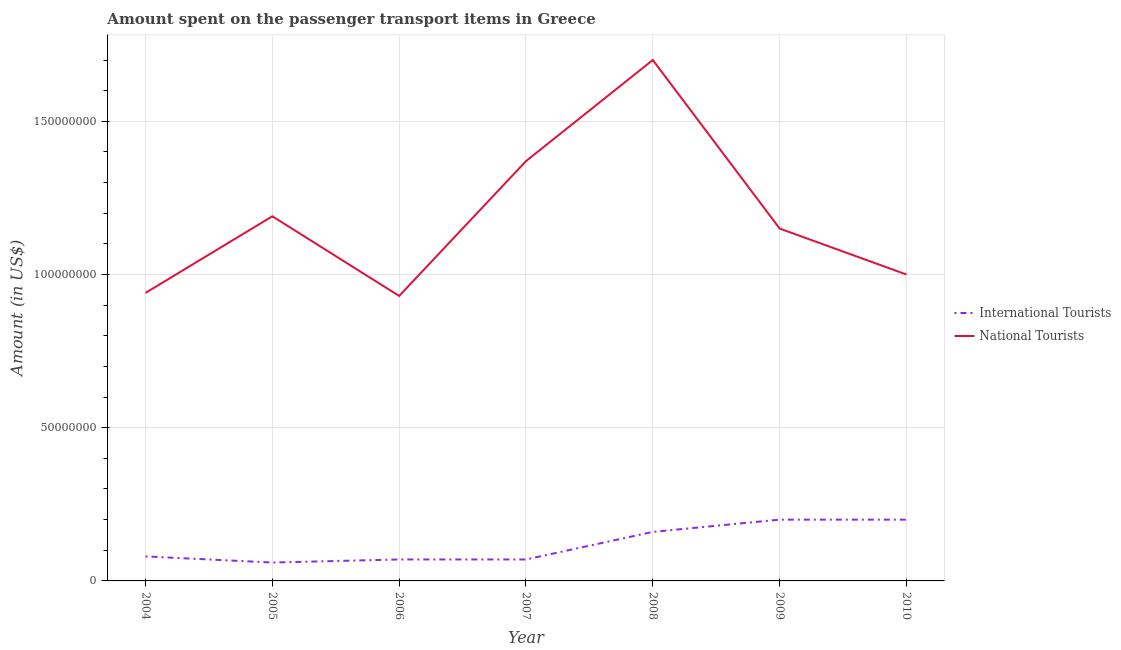How many different coloured lines are there?
Make the answer very short. 2. What is the amount spent on transport items of national tourists in 2007?
Offer a very short reply. 1.37e+08. Across all years, what is the maximum amount spent on transport items of international tourists?
Your response must be concise. 2.00e+07. Across all years, what is the minimum amount spent on transport items of national tourists?
Offer a terse response. 9.30e+07. In which year was the amount spent on transport items of national tourists minimum?
Your answer should be compact. 2006. What is the total amount spent on transport items of international tourists in the graph?
Provide a succinct answer. 8.40e+07. What is the difference between the amount spent on transport items of national tourists in 2007 and that in 2010?
Offer a very short reply. 3.70e+07. What is the difference between the amount spent on transport items of international tourists in 2007 and the amount spent on transport items of national tourists in 2009?
Give a very brief answer. -1.08e+08. What is the average amount spent on transport items of international tourists per year?
Provide a succinct answer. 1.20e+07. In the year 2005, what is the difference between the amount spent on transport items of international tourists and amount spent on transport items of national tourists?
Your answer should be very brief. -1.13e+08. In how many years, is the amount spent on transport items of national tourists greater than 110000000 US$?
Your answer should be compact. 4. What is the difference between the highest and the second highest amount spent on transport items of international tourists?
Offer a very short reply. 0. What is the difference between the highest and the lowest amount spent on transport items of international tourists?
Provide a succinct answer. 1.40e+07. Does the amount spent on transport items of international tourists monotonically increase over the years?
Your answer should be very brief. No. How many lines are there?
Your answer should be very brief. 2. How many years are there in the graph?
Your answer should be very brief. 7. What is the title of the graph?
Keep it short and to the point. Amount spent on the passenger transport items in Greece. Does "Secondary" appear as one of the legend labels in the graph?
Make the answer very short. No. What is the label or title of the X-axis?
Provide a short and direct response. Year. What is the Amount (in US$) in International Tourists in 2004?
Your response must be concise. 8.00e+06. What is the Amount (in US$) in National Tourists in 2004?
Give a very brief answer. 9.40e+07. What is the Amount (in US$) of National Tourists in 2005?
Provide a succinct answer. 1.19e+08. What is the Amount (in US$) of International Tourists in 2006?
Offer a very short reply. 7.00e+06. What is the Amount (in US$) in National Tourists in 2006?
Give a very brief answer. 9.30e+07. What is the Amount (in US$) in National Tourists in 2007?
Offer a very short reply. 1.37e+08. What is the Amount (in US$) in International Tourists in 2008?
Offer a terse response. 1.60e+07. What is the Amount (in US$) of National Tourists in 2008?
Your answer should be compact. 1.70e+08. What is the Amount (in US$) in National Tourists in 2009?
Provide a short and direct response. 1.15e+08. What is the Amount (in US$) of National Tourists in 2010?
Your answer should be very brief. 1.00e+08. Across all years, what is the maximum Amount (in US$) in International Tourists?
Your response must be concise. 2.00e+07. Across all years, what is the maximum Amount (in US$) in National Tourists?
Your answer should be very brief. 1.70e+08. Across all years, what is the minimum Amount (in US$) in National Tourists?
Keep it short and to the point. 9.30e+07. What is the total Amount (in US$) in International Tourists in the graph?
Your response must be concise. 8.40e+07. What is the total Amount (in US$) in National Tourists in the graph?
Ensure brevity in your answer.  8.28e+08. What is the difference between the Amount (in US$) of International Tourists in 2004 and that in 2005?
Give a very brief answer. 2.00e+06. What is the difference between the Amount (in US$) in National Tourists in 2004 and that in 2005?
Offer a terse response. -2.50e+07. What is the difference between the Amount (in US$) of International Tourists in 2004 and that in 2006?
Your response must be concise. 1.00e+06. What is the difference between the Amount (in US$) in National Tourists in 2004 and that in 2007?
Ensure brevity in your answer.  -4.30e+07. What is the difference between the Amount (in US$) in International Tourists in 2004 and that in 2008?
Offer a terse response. -8.00e+06. What is the difference between the Amount (in US$) of National Tourists in 2004 and that in 2008?
Provide a succinct answer. -7.60e+07. What is the difference between the Amount (in US$) in International Tourists in 2004 and that in 2009?
Your answer should be very brief. -1.20e+07. What is the difference between the Amount (in US$) in National Tourists in 2004 and that in 2009?
Provide a short and direct response. -2.10e+07. What is the difference between the Amount (in US$) of International Tourists in 2004 and that in 2010?
Make the answer very short. -1.20e+07. What is the difference between the Amount (in US$) in National Tourists in 2004 and that in 2010?
Your response must be concise. -6.00e+06. What is the difference between the Amount (in US$) in National Tourists in 2005 and that in 2006?
Make the answer very short. 2.60e+07. What is the difference between the Amount (in US$) of International Tourists in 2005 and that in 2007?
Ensure brevity in your answer.  -1.00e+06. What is the difference between the Amount (in US$) in National Tourists in 2005 and that in 2007?
Give a very brief answer. -1.80e+07. What is the difference between the Amount (in US$) of International Tourists in 2005 and that in 2008?
Your answer should be compact. -1.00e+07. What is the difference between the Amount (in US$) of National Tourists in 2005 and that in 2008?
Provide a succinct answer. -5.10e+07. What is the difference between the Amount (in US$) in International Tourists in 2005 and that in 2009?
Provide a short and direct response. -1.40e+07. What is the difference between the Amount (in US$) of International Tourists in 2005 and that in 2010?
Provide a short and direct response. -1.40e+07. What is the difference between the Amount (in US$) in National Tourists in 2005 and that in 2010?
Provide a succinct answer. 1.90e+07. What is the difference between the Amount (in US$) of National Tourists in 2006 and that in 2007?
Your answer should be very brief. -4.40e+07. What is the difference between the Amount (in US$) in International Tourists in 2006 and that in 2008?
Ensure brevity in your answer.  -9.00e+06. What is the difference between the Amount (in US$) in National Tourists in 2006 and that in 2008?
Make the answer very short. -7.70e+07. What is the difference between the Amount (in US$) of International Tourists in 2006 and that in 2009?
Your answer should be compact. -1.30e+07. What is the difference between the Amount (in US$) in National Tourists in 2006 and that in 2009?
Your response must be concise. -2.20e+07. What is the difference between the Amount (in US$) of International Tourists in 2006 and that in 2010?
Your answer should be very brief. -1.30e+07. What is the difference between the Amount (in US$) of National Tourists in 2006 and that in 2010?
Make the answer very short. -7.00e+06. What is the difference between the Amount (in US$) of International Tourists in 2007 and that in 2008?
Your answer should be compact. -9.00e+06. What is the difference between the Amount (in US$) in National Tourists in 2007 and that in 2008?
Offer a terse response. -3.30e+07. What is the difference between the Amount (in US$) in International Tourists in 2007 and that in 2009?
Your answer should be very brief. -1.30e+07. What is the difference between the Amount (in US$) in National Tourists in 2007 and that in 2009?
Your answer should be compact. 2.20e+07. What is the difference between the Amount (in US$) in International Tourists in 2007 and that in 2010?
Provide a short and direct response. -1.30e+07. What is the difference between the Amount (in US$) of National Tourists in 2007 and that in 2010?
Provide a succinct answer. 3.70e+07. What is the difference between the Amount (in US$) of National Tourists in 2008 and that in 2009?
Make the answer very short. 5.50e+07. What is the difference between the Amount (in US$) of International Tourists in 2008 and that in 2010?
Your answer should be very brief. -4.00e+06. What is the difference between the Amount (in US$) of National Tourists in 2008 and that in 2010?
Give a very brief answer. 7.00e+07. What is the difference between the Amount (in US$) of National Tourists in 2009 and that in 2010?
Provide a succinct answer. 1.50e+07. What is the difference between the Amount (in US$) in International Tourists in 2004 and the Amount (in US$) in National Tourists in 2005?
Give a very brief answer. -1.11e+08. What is the difference between the Amount (in US$) of International Tourists in 2004 and the Amount (in US$) of National Tourists in 2006?
Make the answer very short. -8.50e+07. What is the difference between the Amount (in US$) of International Tourists in 2004 and the Amount (in US$) of National Tourists in 2007?
Offer a terse response. -1.29e+08. What is the difference between the Amount (in US$) of International Tourists in 2004 and the Amount (in US$) of National Tourists in 2008?
Your answer should be very brief. -1.62e+08. What is the difference between the Amount (in US$) in International Tourists in 2004 and the Amount (in US$) in National Tourists in 2009?
Give a very brief answer. -1.07e+08. What is the difference between the Amount (in US$) in International Tourists in 2004 and the Amount (in US$) in National Tourists in 2010?
Offer a very short reply. -9.20e+07. What is the difference between the Amount (in US$) in International Tourists in 2005 and the Amount (in US$) in National Tourists in 2006?
Ensure brevity in your answer.  -8.70e+07. What is the difference between the Amount (in US$) in International Tourists in 2005 and the Amount (in US$) in National Tourists in 2007?
Provide a succinct answer. -1.31e+08. What is the difference between the Amount (in US$) of International Tourists in 2005 and the Amount (in US$) of National Tourists in 2008?
Provide a succinct answer. -1.64e+08. What is the difference between the Amount (in US$) in International Tourists in 2005 and the Amount (in US$) in National Tourists in 2009?
Provide a short and direct response. -1.09e+08. What is the difference between the Amount (in US$) in International Tourists in 2005 and the Amount (in US$) in National Tourists in 2010?
Keep it short and to the point. -9.40e+07. What is the difference between the Amount (in US$) in International Tourists in 2006 and the Amount (in US$) in National Tourists in 2007?
Provide a succinct answer. -1.30e+08. What is the difference between the Amount (in US$) of International Tourists in 2006 and the Amount (in US$) of National Tourists in 2008?
Keep it short and to the point. -1.63e+08. What is the difference between the Amount (in US$) in International Tourists in 2006 and the Amount (in US$) in National Tourists in 2009?
Your answer should be very brief. -1.08e+08. What is the difference between the Amount (in US$) in International Tourists in 2006 and the Amount (in US$) in National Tourists in 2010?
Your answer should be compact. -9.30e+07. What is the difference between the Amount (in US$) of International Tourists in 2007 and the Amount (in US$) of National Tourists in 2008?
Give a very brief answer. -1.63e+08. What is the difference between the Amount (in US$) in International Tourists in 2007 and the Amount (in US$) in National Tourists in 2009?
Provide a succinct answer. -1.08e+08. What is the difference between the Amount (in US$) of International Tourists in 2007 and the Amount (in US$) of National Tourists in 2010?
Give a very brief answer. -9.30e+07. What is the difference between the Amount (in US$) of International Tourists in 2008 and the Amount (in US$) of National Tourists in 2009?
Your answer should be very brief. -9.90e+07. What is the difference between the Amount (in US$) of International Tourists in 2008 and the Amount (in US$) of National Tourists in 2010?
Give a very brief answer. -8.40e+07. What is the difference between the Amount (in US$) of International Tourists in 2009 and the Amount (in US$) of National Tourists in 2010?
Your response must be concise. -8.00e+07. What is the average Amount (in US$) of National Tourists per year?
Your response must be concise. 1.18e+08. In the year 2004, what is the difference between the Amount (in US$) of International Tourists and Amount (in US$) of National Tourists?
Your answer should be compact. -8.60e+07. In the year 2005, what is the difference between the Amount (in US$) in International Tourists and Amount (in US$) in National Tourists?
Make the answer very short. -1.13e+08. In the year 2006, what is the difference between the Amount (in US$) in International Tourists and Amount (in US$) in National Tourists?
Keep it short and to the point. -8.60e+07. In the year 2007, what is the difference between the Amount (in US$) of International Tourists and Amount (in US$) of National Tourists?
Provide a short and direct response. -1.30e+08. In the year 2008, what is the difference between the Amount (in US$) of International Tourists and Amount (in US$) of National Tourists?
Provide a succinct answer. -1.54e+08. In the year 2009, what is the difference between the Amount (in US$) of International Tourists and Amount (in US$) of National Tourists?
Your response must be concise. -9.50e+07. In the year 2010, what is the difference between the Amount (in US$) of International Tourists and Amount (in US$) of National Tourists?
Offer a terse response. -8.00e+07. What is the ratio of the Amount (in US$) of National Tourists in 2004 to that in 2005?
Make the answer very short. 0.79. What is the ratio of the Amount (in US$) in International Tourists in 2004 to that in 2006?
Keep it short and to the point. 1.14. What is the ratio of the Amount (in US$) in National Tourists in 2004 to that in 2006?
Your response must be concise. 1.01. What is the ratio of the Amount (in US$) in International Tourists in 2004 to that in 2007?
Make the answer very short. 1.14. What is the ratio of the Amount (in US$) of National Tourists in 2004 to that in 2007?
Keep it short and to the point. 0.69. What is the ratio of the Amount (in US$) of National Tourists in 2004 to that in 2008?
Your answer should be very brief. 0.55. What is the ratio of the Amount (in US$) in National Tourists in 2004 to that in 2009?
Give a very brief answer. 0.82. What is the ratio of the Amount (in US$) of International Tourists in 2004 to that in 2010?
Your response must be concise. 0.4. What is the ratio of the Amount (in US$) in National Tourists in 2004 to that in 2010?
Keep it short and to the point. 0.94. What is the ratio of the Amount (in US$) of International Tourists in 2005 to that in 2006?
Ensure brevity in your answer.  0.86. What is the ratio of the Amount (in US$) in National Tourists in 2005 to that in 2006?
Your response must be concise. 1.28. What is the ratio of the Amount (in US$) in International Tourists in 2005 to that in 2007?
Your answer should be very brief. 0.86. What is the ratio of the Amount (in US$) of National Tourists in 2005 to that in 2007?
Your response must be concise. 0.87. What is the ratio of the Amount (in US$) in International Tourists in 2005 to that in 2008?
Ensure brevity in your answer.  0.38. What is the ratio of the Amount (in US$) in National Tourists in 2005 to that in 2008?
Provide a short and direct response. 0.7. What is the ratio of the Amount (in US$) in National Tourists in 2005 to that in 2009?
Make the answer very short. 1.03. What is the ratio of the Amount (in US$) in International Tourists in 2005 to that in 2010?
Offer a terse response. 0.3. What is the ratio of the Amount (in US$) of National Tourists in 2005 to that in 2010?
Your answer should be compact. 1.19. What is the ratio of the Amount (in US$) in International Tourists in 2006 to that in 2007?
Ensure brevity in your answer.  1. What is the ratio of the Amount (in US$) in National Tourists in 2006 to that in 2007?
Offer a terse response. 0.68. What is the ratio of the Amount (in US$) of International Tourists in 2006 to that in 2008?
Your response must be concise. 0.44. What is the ratio of the Amount (in US$) in National Tourists in 2006 to that in 2008?
Give a very brief answer. 0.55. What is the ratio of the Amount (in US$) of National Tourists in 2006 to that in 2009?
Ensure brevity in your answer.  0.81. What is the ratio of the Amount (in US$) in International Tourists in 2006 to that in 2010?
Provide a short and direct response. 0.35. What is the ratio of the Amount (in US$) of International Tourists in 2007 to that in 2008?
Make the answer very short. 0.44. What is the ratio of the Amount (in US$) of National Tourists in 2007 to that in 2008?
Your answer should be compact. 0.81. What is the ratio of the Amount (in US$) of National Tourists in 2007 to that in 2009?
Offer a terse response. 1.19. What is the ratio of the Amount (in US$) of National Tourists in 2007 to that in 2010?
Provide a succinct answer. 1.37. What is the ratio of the Amount (in US$) of International Tourists in 2008 to that in 2009?
Offer a terse response. 0.8. What is the ratio of the Amount (in US$) of National Tourists in 2008 to that in 2009?
Your answer should be compact. 1.48. What is the ratio of the Amount (in US$) of International Tourists in 2008 to that in 2010?
Provide a short and direct response. 0.8. What is the ratio of the Amount (in US$) in National Tourists in 2008 to that in 2010?
Give a very brief answer. 1.7. What is the ratio of the Amount (in US$) of National Tourists in 2009 to that in 2010?
Provide a succinct answer. 1.15. What is the difference between the highest and the second highest Amount (in US$) in National Tourists?
Offer a terse response. 3.30e+07. What is the difference between the highest and the lowest Amount (in US$) of International Tourists?
Keep it short and to the point. 1.40e+07. What is the difference between the highest and the lowest Amount (in US$) in National Tourists?
Provide a succinct answer. 7.70e+07. 